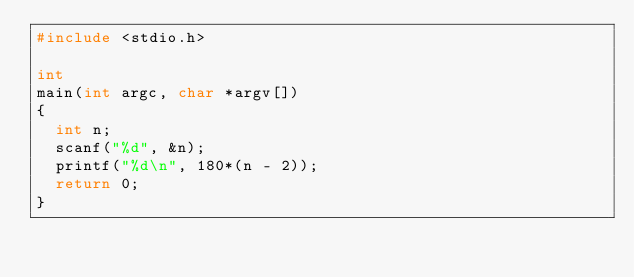<code> <loc_0><loc_0><loc_500><loc_500><_C_>#include <stdio.h>

int
main(int argc, char *argv[])
{
  int n;
  scanf("%d", &n);
  printf("%d\n", 180*(n - 2));
  return 0;
}
 </code> 